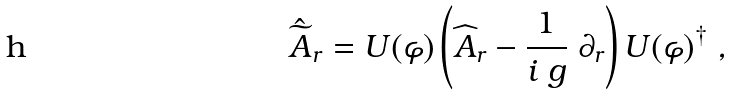<formula> <loc_0><loc_0><loc_500><loc_500>\hat { \widetilde { A } } _ { r } = U ( \varphi ) \left ( \widehat { A } _ { r } - \frac { 1 } { i \ g } \ \partial _ { r } \right ) U ( \varphi ) ^ { \dagger } \ ,</formula> 